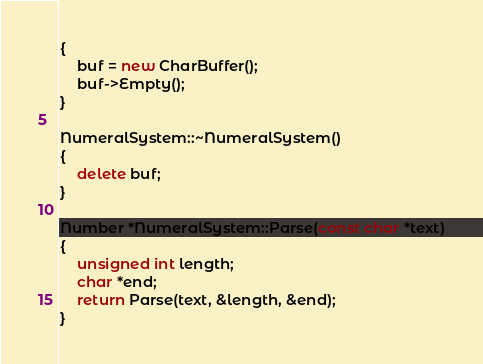Convert code to text. <code><loc_0><loc_0><loc_500><loc_500><_C++_>{
    buf = new CharBuffer();
    buf->Empty();
}

NumeralSystem::~NumeralSystem()
{
    delete buf;
}

Number *NumeralSystem::Parse(const char *text)
{
    unsigned int length;
    char *end;
    return Parse(text, &length, &end);
}
</code> 